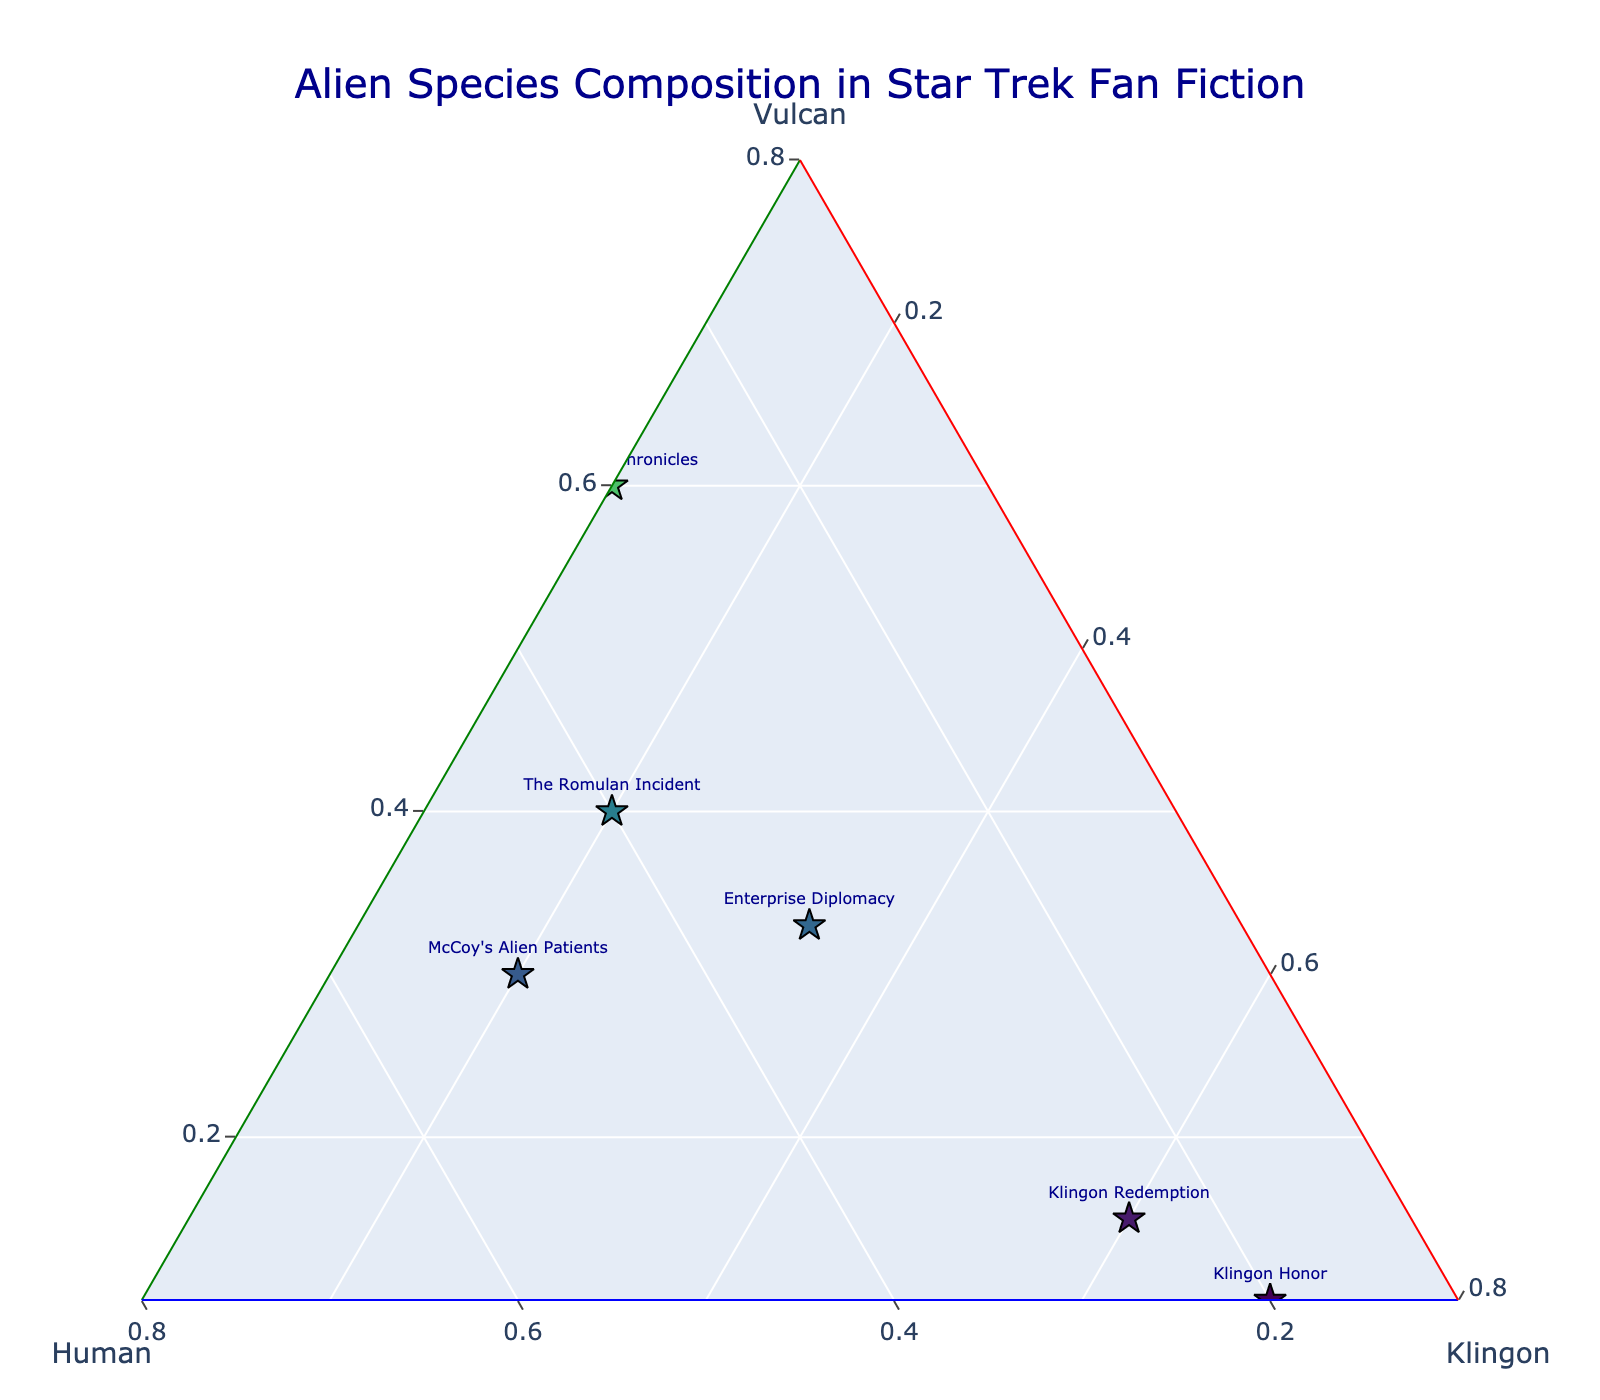What is the title of the figure? The title of the figure is typically located at the top. In this case, it is written in dark blue text near the top center. It says, "Alien Species Composition in Star Trek Fan Fiction."
Answer: Alien Species Composition in Star Trek Fan Fiction Which story has the highest Vulcan composition? By observing the ternary plot, you can see that the data point labeled "Spock's Dilemma" is positioned closest to the Vulcan apex, indicating the highest Vulcan composition.
Answer: Spock's Dilemma How does "Enterprise Diplomacy" compare to "Vulcan-Human Alliance" in terms of Klingon composition? "Enterprise Diplomacy" and "Vulcan-Human Alliance" can be compared by their positions relative to the Klingon apex. "Enterprise Diplomacy" has nearly equal parts Vulcan, Human, and Klingon, while "Vulcan-Human Alliance" has very low Klingon composition. Therefore, "Enterprise Diplomacy" has a higher Klingon composition.
Answer: Enterprise Diplomacy has higher Klingon composition What is the average Vulcan composition across all stories? To find the average Vulcan composition, add up all the Vulcan values and divide by the number of stories. (0.6 + 0.8 + 0.1 + 0.33 + 0.25 + 0.5 + 0.15 + 0.2 + 0.4 + 0.3) / 10 = 3.63 / 10 = 0.363
Answer: 0.363 Which story has nearly equal composition of all three species? On the ternary plot, the story "Enterprise Diplomacy" is positioned close to the center of the plot, indicating it has nearly equal parts Vulcan, Human, and Klingon.
Answer: Enterprise Diplomacy What are the compositions of Human and Klingon in "McCoy's Alien Patients"? By referring to the point labeled "McCoy's Alien Patients" on the ternary plot, we see it is visualized with approximately 0.5 Human and 0.2 Klingon composition values.
Answer: 0.5 Human, 0.2 Klingon Which stories feature a higher Human composition than Vulcan composition? By observing the plot and the position of data points relative to the Vulcan-Human axis, the stories with a higher Human composition than Vulcan are "Nichelle's Legacy" and "Starfleet Academy Days".
Answer: Nichelle's Legacy, Starfleet Academy Days What's the difference in Human composition between "The Uhura Chronicles" and "Klingon Redemption"? From the ternary plot, "The Uhura Chronicles" has 0.3 Human composition while "Klingon Redemption" has 0.25. The difference is 0.3 - 0.25 = 0.05.
Answer: 0.05 Is "The Romulan Incident" higher in Human or Klingon composition? The data point for "The Romulan Incident" is closer to the Human apex than to the Klingon apex, indicating it has a higher Human composition.
Answer: Human 